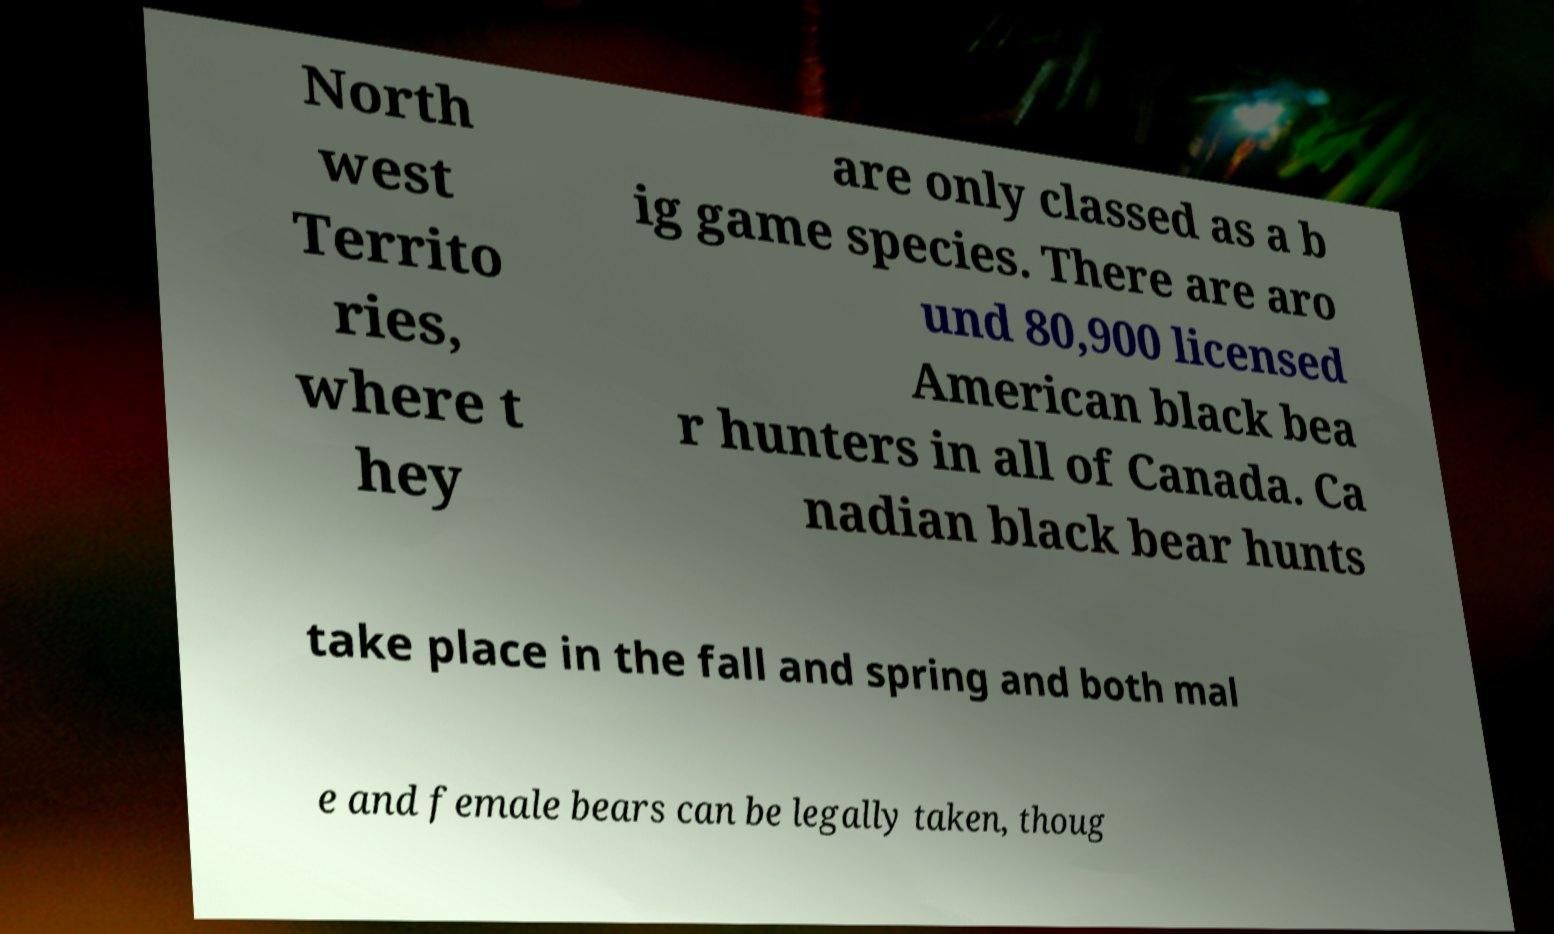For documentation purposes, I need the text within this image transcribed. Could you provide that? North west Territo ries, where t hey are only classed as a b ig game species. There are aro und 80,900 licensed American black bea r hunters in all of Canada. Ca nadian black bear hunts take place in the fall and spring and both mal e and female bears can be legally taken, thoug 